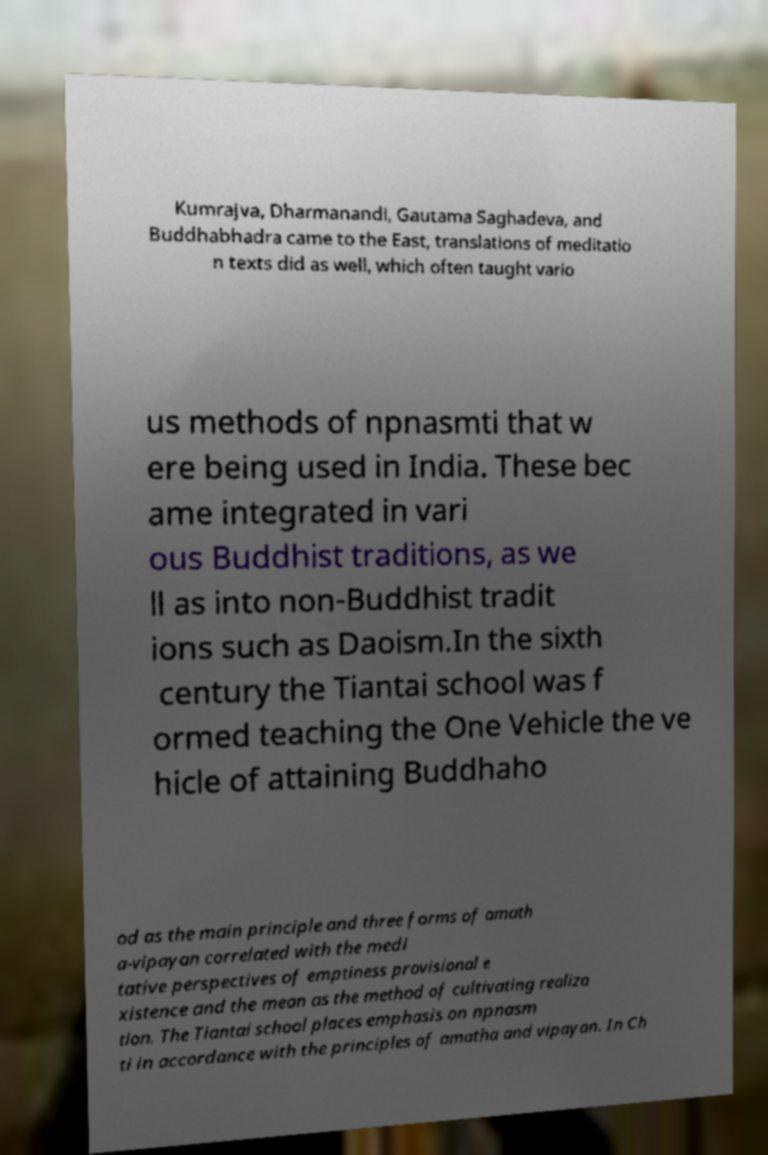I need the written content from this picture converted into text. Can you do that? Kumrajva, Dharmanandi, Gautama Saghadeva, and Buddhabhadra came to the East, translations of meditatio n texts did as well, which often taught vario us methods of npnasmti that w ere being used in India. These bec ame integrated in vari ous Buddhist traditions, as we ll as into non-Buddhist tradit ions such as Daoism.In the sixth century the Tiantai school was f ormed teaching the One Vehicle the ve hicle of attaining Buddhaho od as the main principle and three forms of amath a-vipayan correlated with the medi tative perspectives of emptiness provisional e xistence and the mean as the method of cultivating realiza tion. The Tiantai school places emphasis on npnasm ti in accordance with the principles of amatha and vipayan. In Ch 